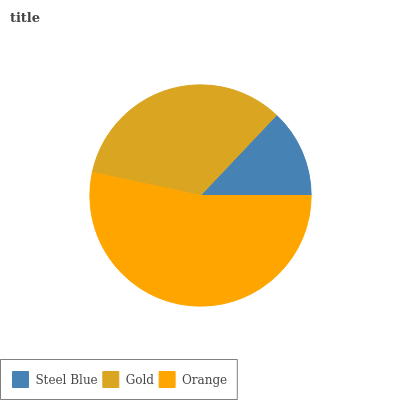Is Steel Blue the minimum?
Answer yes or no. Yes. Is Orange the maximum?
Answer yes or no. Yes. Is Gold the minimum?
Answer yes or no. No. Is Gold the maximum?
Answer yes or no. No. Is Gold greater than Steel Blue?
Answer yes or no. Yes. Is Steel Blue less than Gold?
Answer yes or no. Yes. Is Steel Blue greater than Gold?
Answer yes or no. No. Is Gold less than Steel Blue?
Answer yes or no. No. Is Gold the high median?
Answer yes or no. Yes. Is Gold the low median?
Answer yes or no. Yes. Is Steel Blue the high median?
Answer yes or no. No. Is Orange the low median?
Answer yes or no. No. 